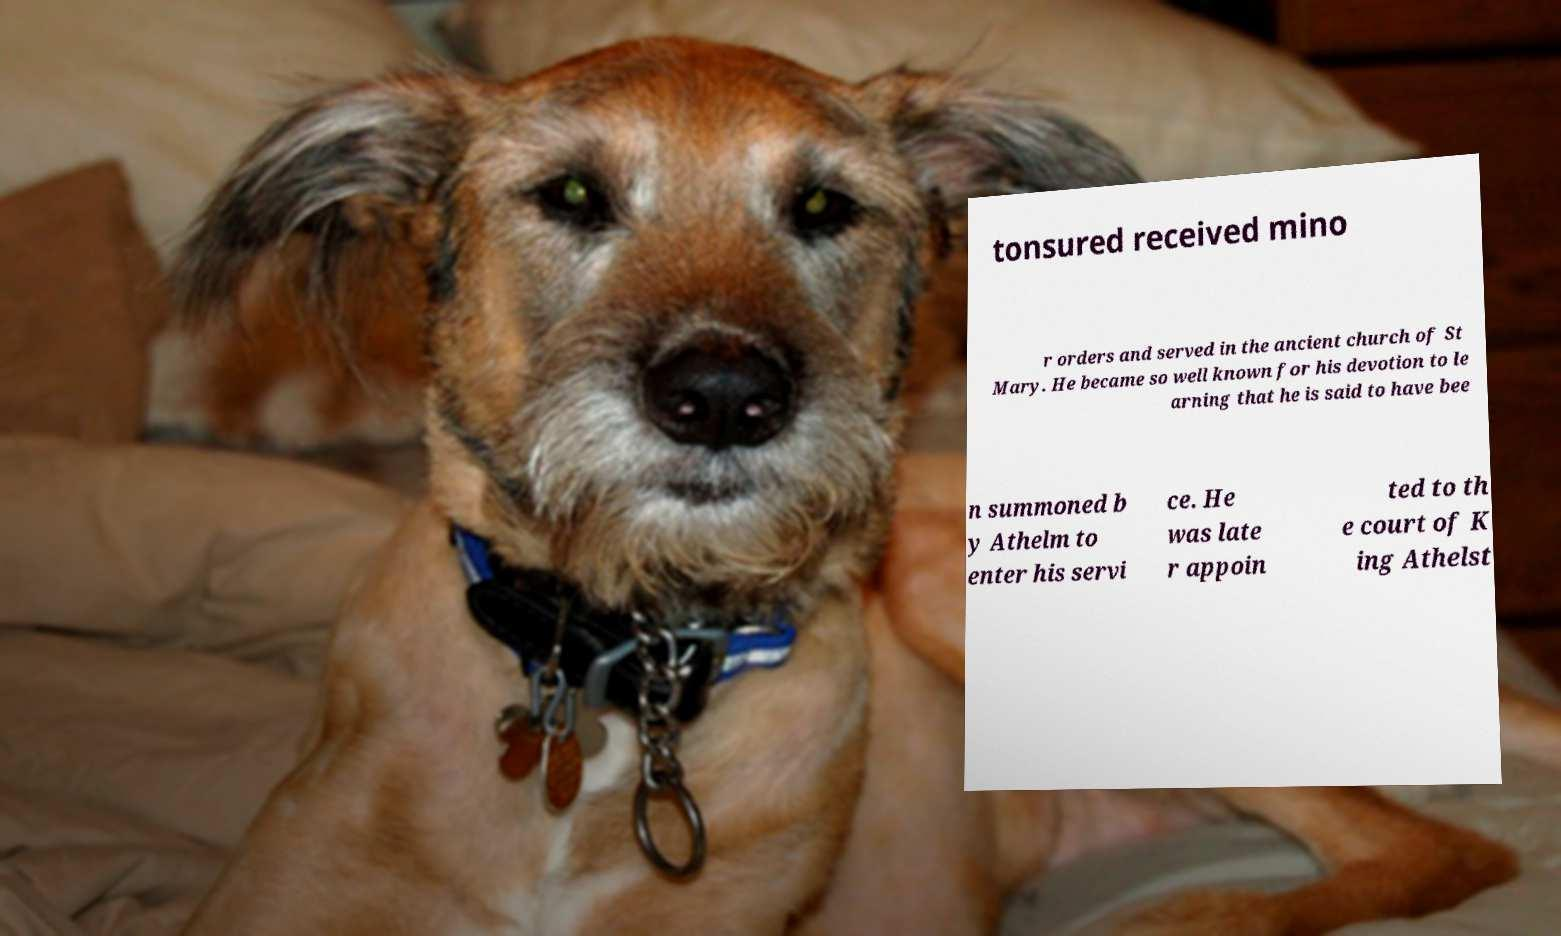For documentation purposes, I need the text within this image transcribed. Could you provide that? tonsured received mino r orders and served in the ancient church of St Mary. He became so well known for his devotion to le arning that he is said to have bee n summoned b y Athelm to enter his servi ce. He was late r appoin ted to th e court of K ing Athelst 